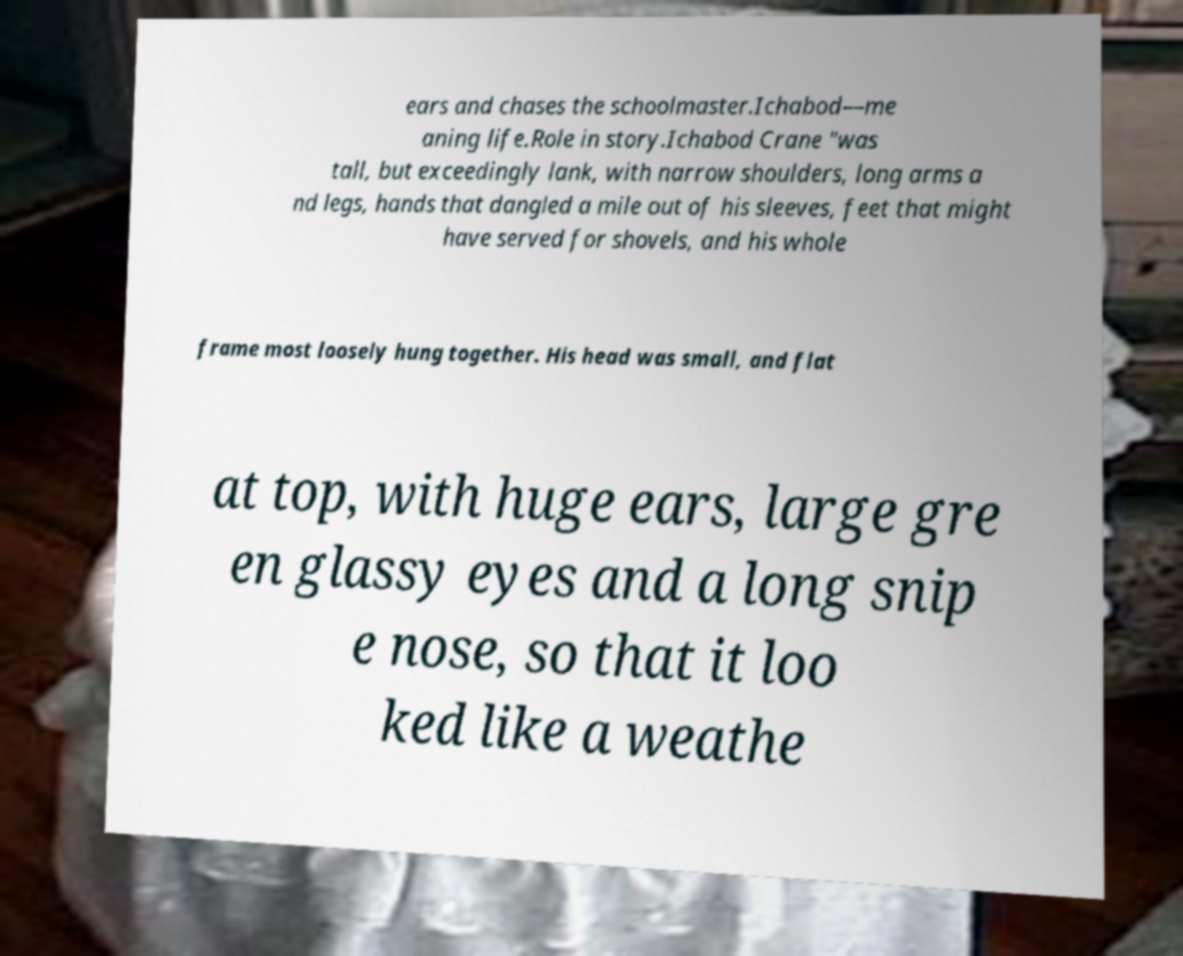What messages or text are displayed in this image? I need them in a readable, typed format. ears and chases the schoolmaster.Ichabod—me aning life.Role in story.Ichabod Crane "was tall, but exceedingly lank, with narrow shoulders, long arms a nd legs, hands that dangled a mile out of his sleeves, feet that might have served for shovels, and his whole frame most loosely hung together. His head was small, and flat at top, with huge ears, large gre en glassy eyes and a long snip e nose, so that it loo ked like a weathe 